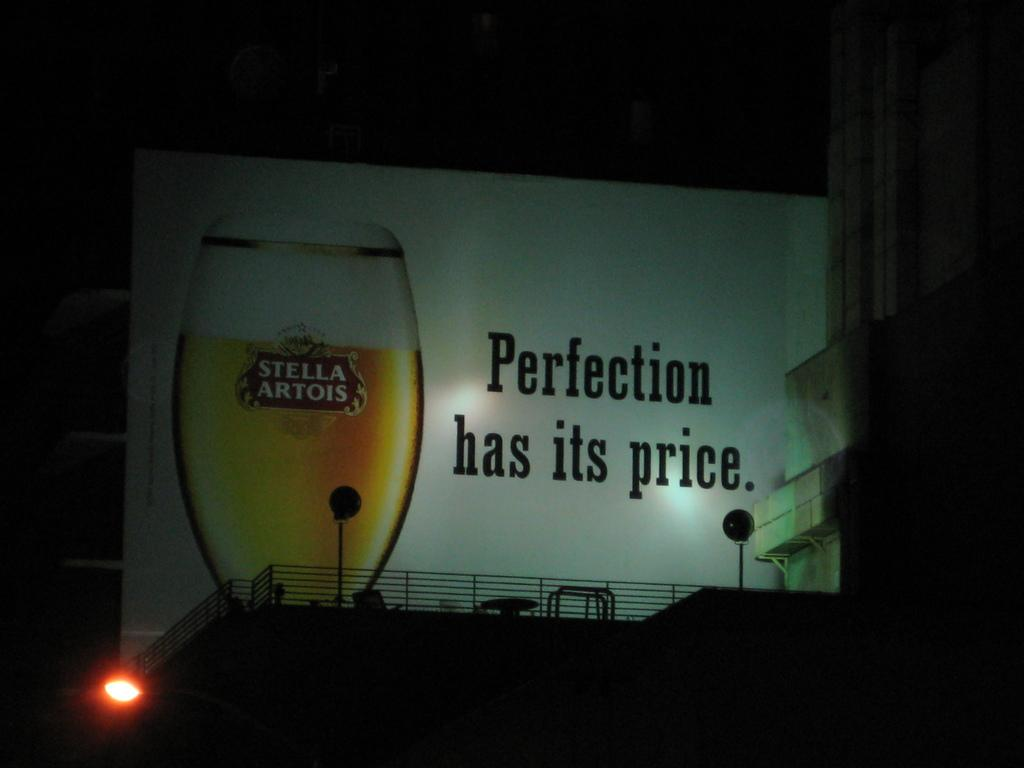<image>
Describe the image concisely. Billboard that says "Perfection has it's price" with a Stella Artois cup next toi t. 